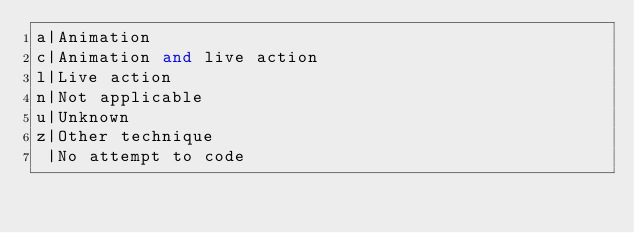<code> <loc_0><loc_0><loc_500><loc_500><_SQL_>a|Animation 
c|Animation and live action 
l|Live action 
n|Not applicable 
u|Unknown 
z|Other technique 
 |No attempt to code
</code> 